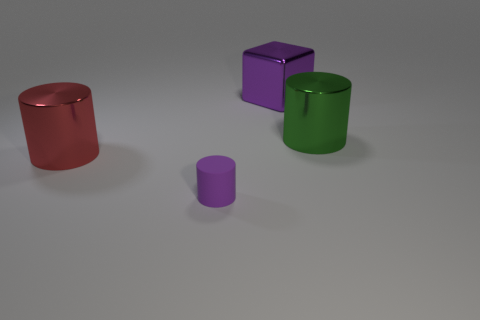Subtract all purple cylinders. How many cylinders are left? 2 Subtract 1 cylinders. How many cylinders are left? 2 Add 1 cylinders. How many objects exist? 5 Subtract all cylinders. How many objects are left? 1 Subtract all brown cylinders. Subtract all cyan cubes. How many cylinders are left? 3 Subtract 0 red cubes. How many objects are left? 4 Subtract all small purple rubber cylinders. Subtract all purple shiny blocks. How many objects are left? 2 Add 4 purple matte objects. How many purple matte objects are left? 5 Add 4 big gray metal balls. How many big gray metal balls exist? 4 